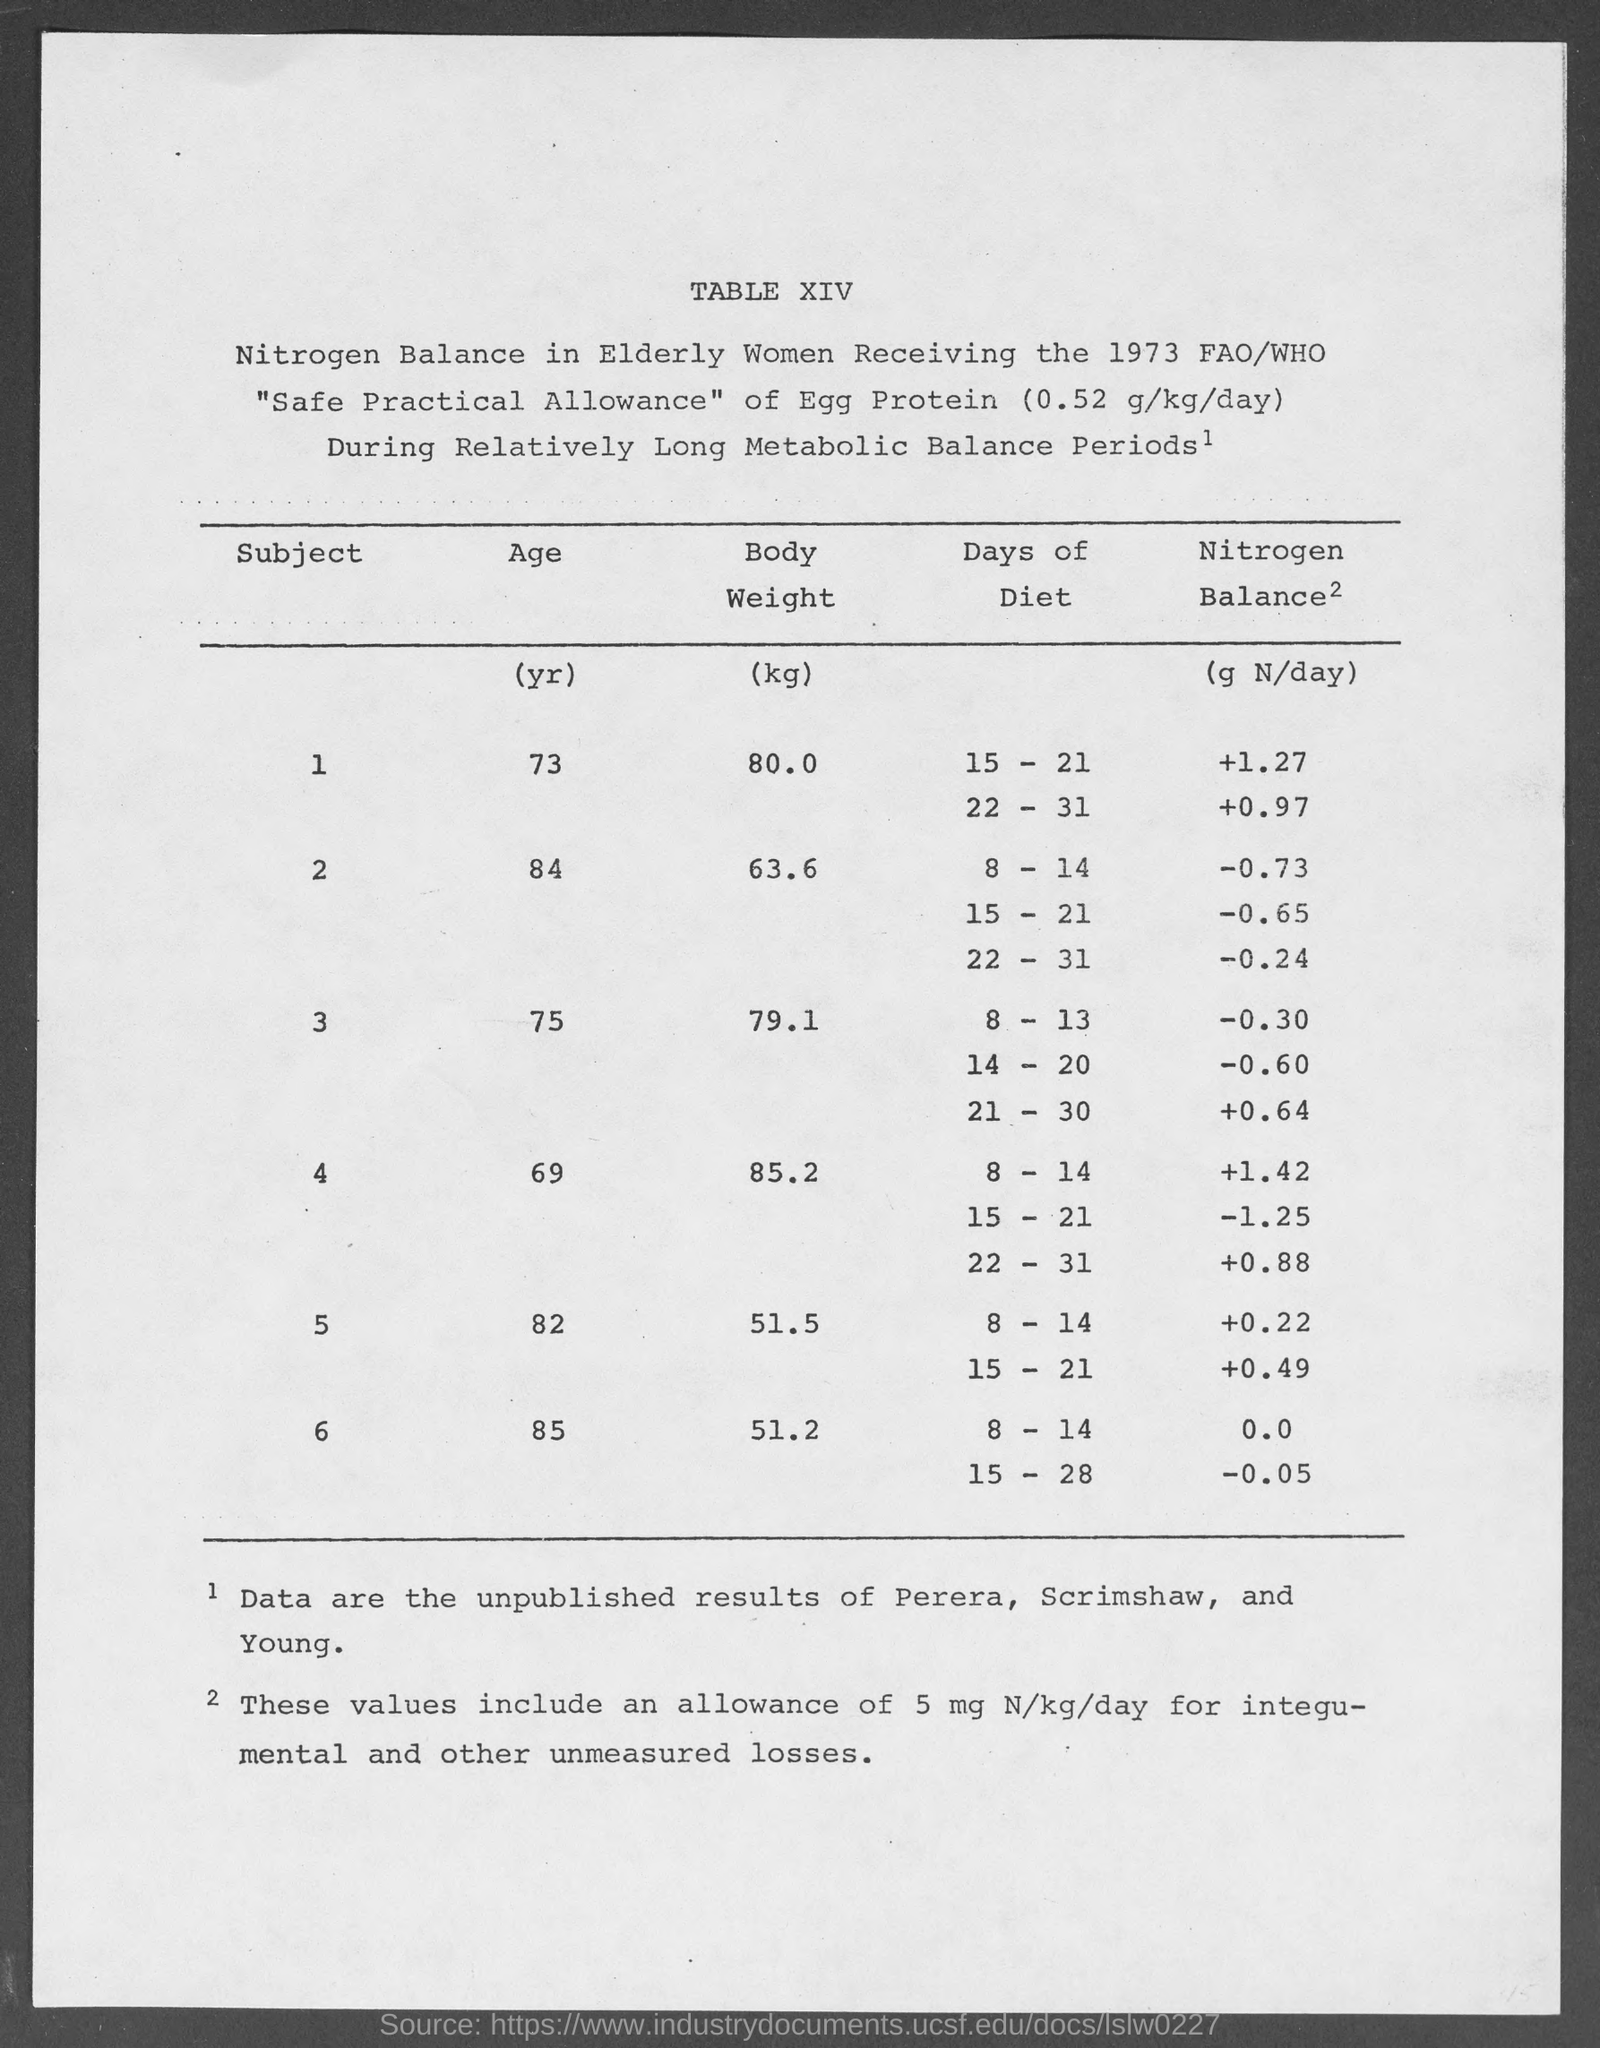What is the body weight for the age 73 yr as mentioned in the given table ?
Provide a short and direct response. 80.0. What is the body weight for the age 84 yr as mentioned in the given table ?
Keep it short and to the point. 63.6. What is the body weight for the age 75 yr as mentioned in the given table ?
Provide a succinct answer. 79.1. What is the body weight for the age 69 yr as mentioned in the given table ?
Ensure brevity in your answer.  85.2. What is the body weight for the age 82 yr as mentioned in the given table ?
Make the answer very short. 51.5. What is the body weight for the age 85 yr as mentioned in the given table ?
Provide a succinct answer. 51.2. 